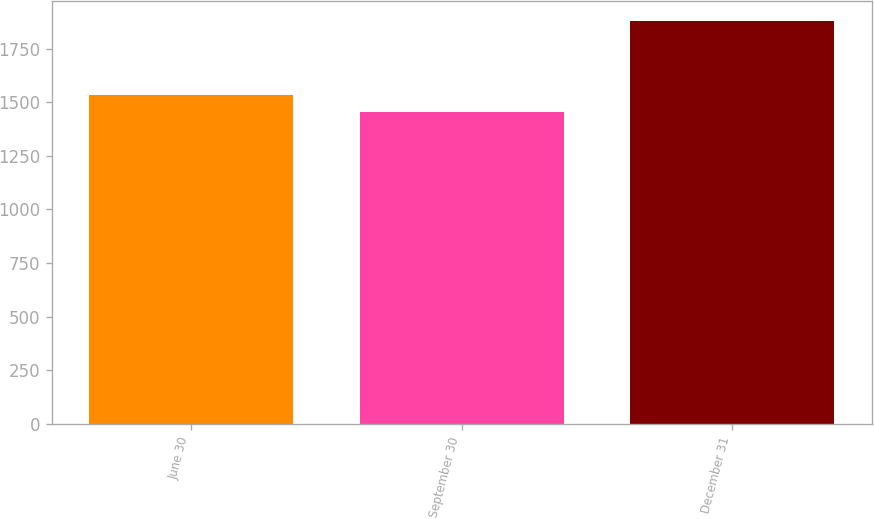Convert chart to OTSL. <chart><loc_0><loc_0><loc_500><loc_500><bar_chart><fcel>June 30<fcel>September 30<fcel>December 31<nl><fcel>1532.9<fcel>1453.8<fcel>1877.1<nl></chart> 